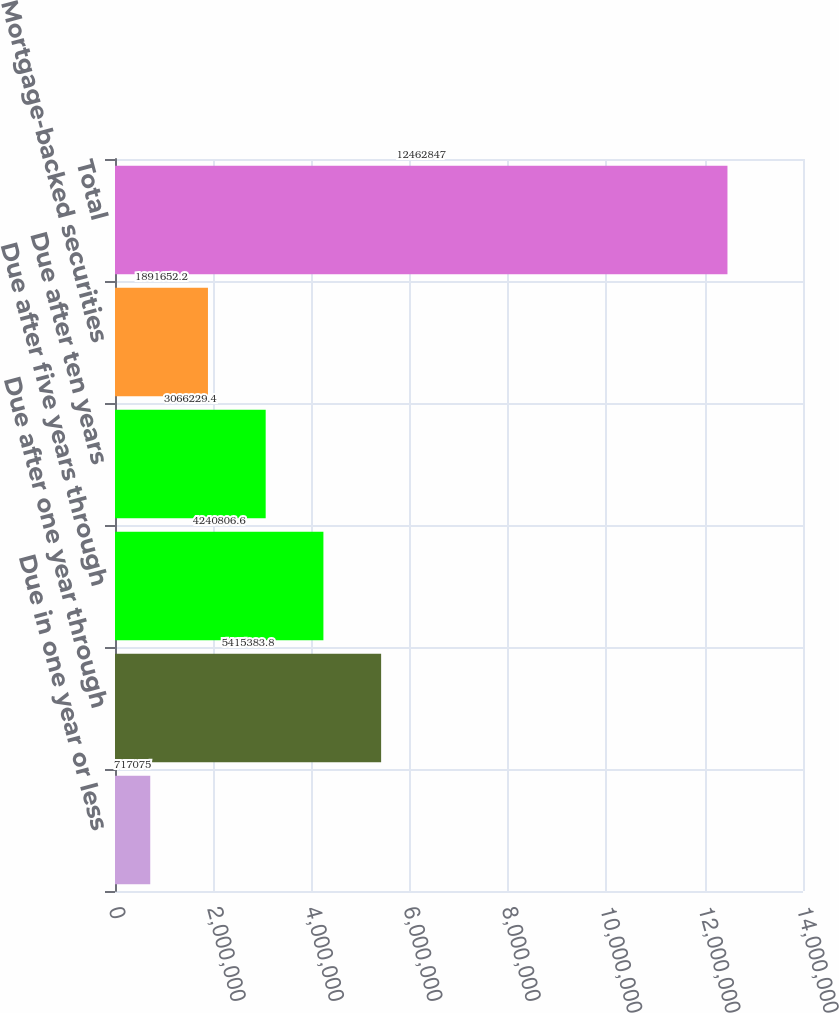Convert chart. <chart><loc_0><loc_0><loc_500><loc_500><bar_chart><fcel>Due in one year or less<fcel>Due after one year through<fcel>Due after five years through<fcel>Due after ten years<fcel>Mortgage-backed securities<fcel>Total<nl><fcel>717075<fcel>5.41538e+06<fcel>4.24081e+06<fcel>3.06623e+06<fcel>1.89165e+06<fcel>1.24628e+07<nl></chart> 